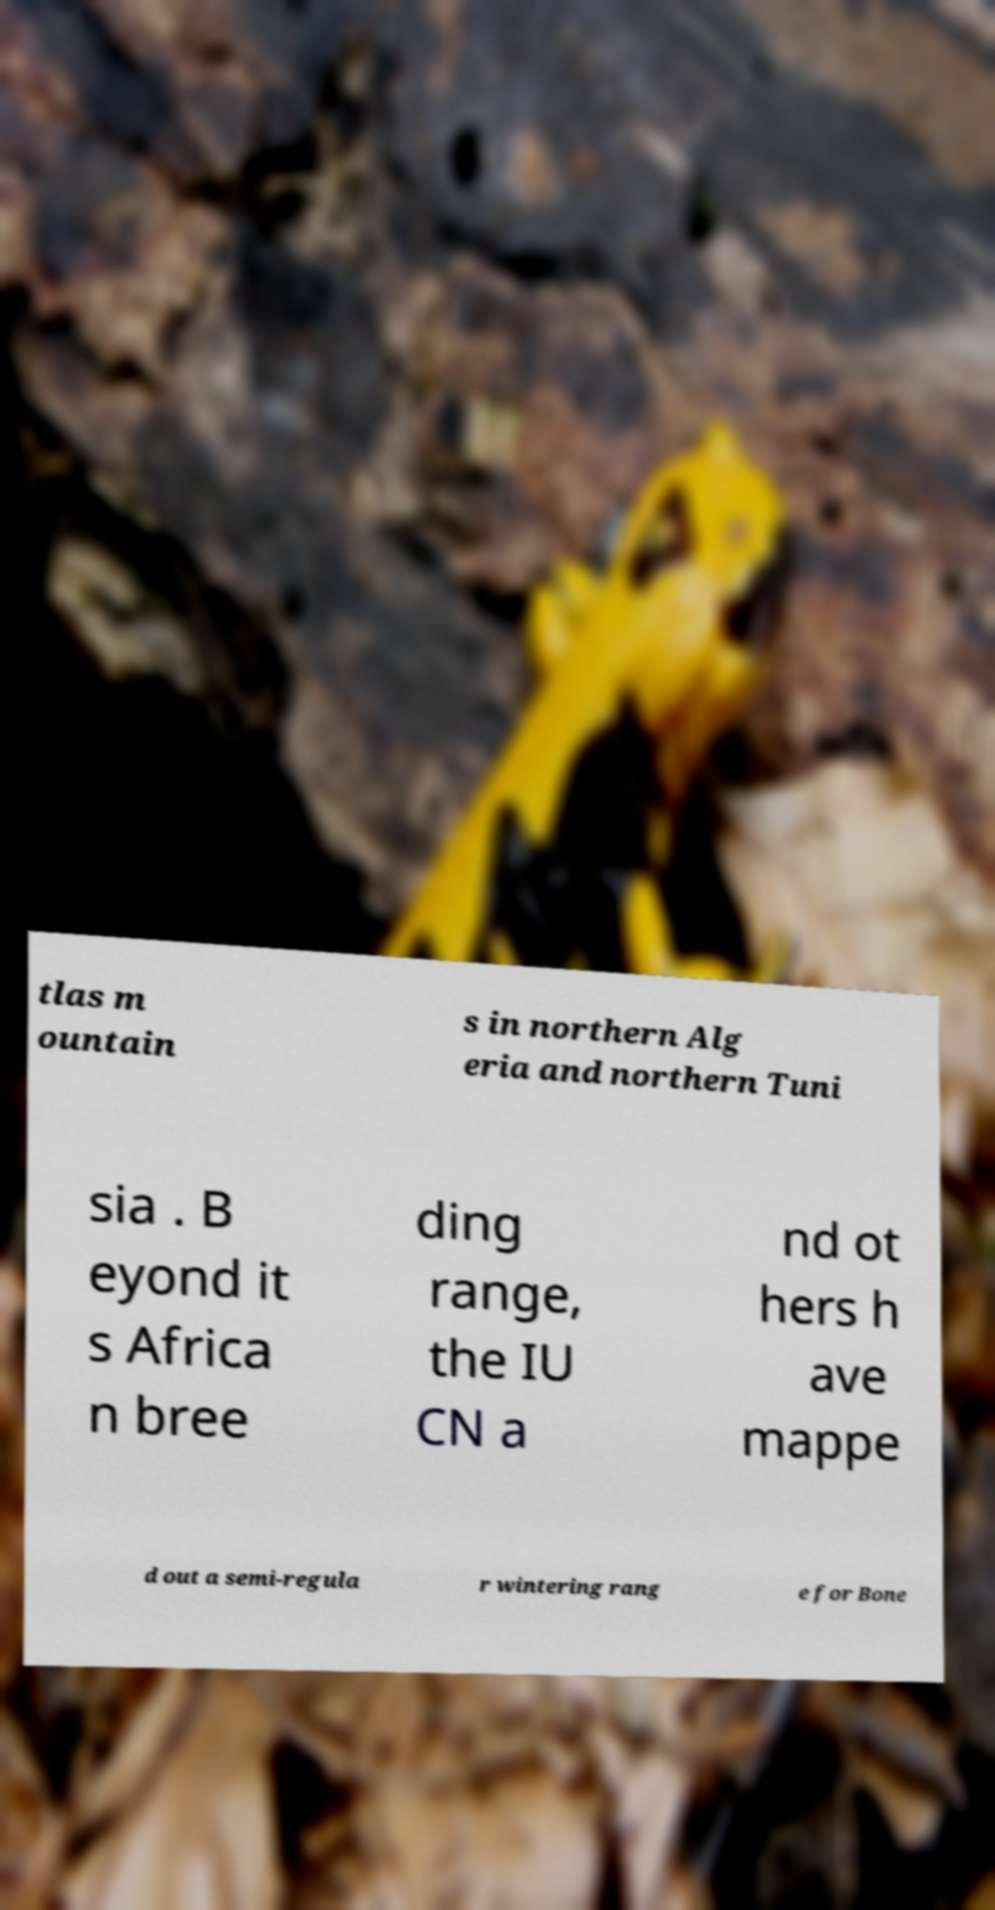What messages or text are displayed in this image? I need them in a readable, typed format. tlas m ountain s in northern Alg eria and northern Tuni sia . B eyond it s Africa n bree ding range, the IU CN a nd ot hers h ave mappe d out a semi-regula r wintering rang e for Bone 